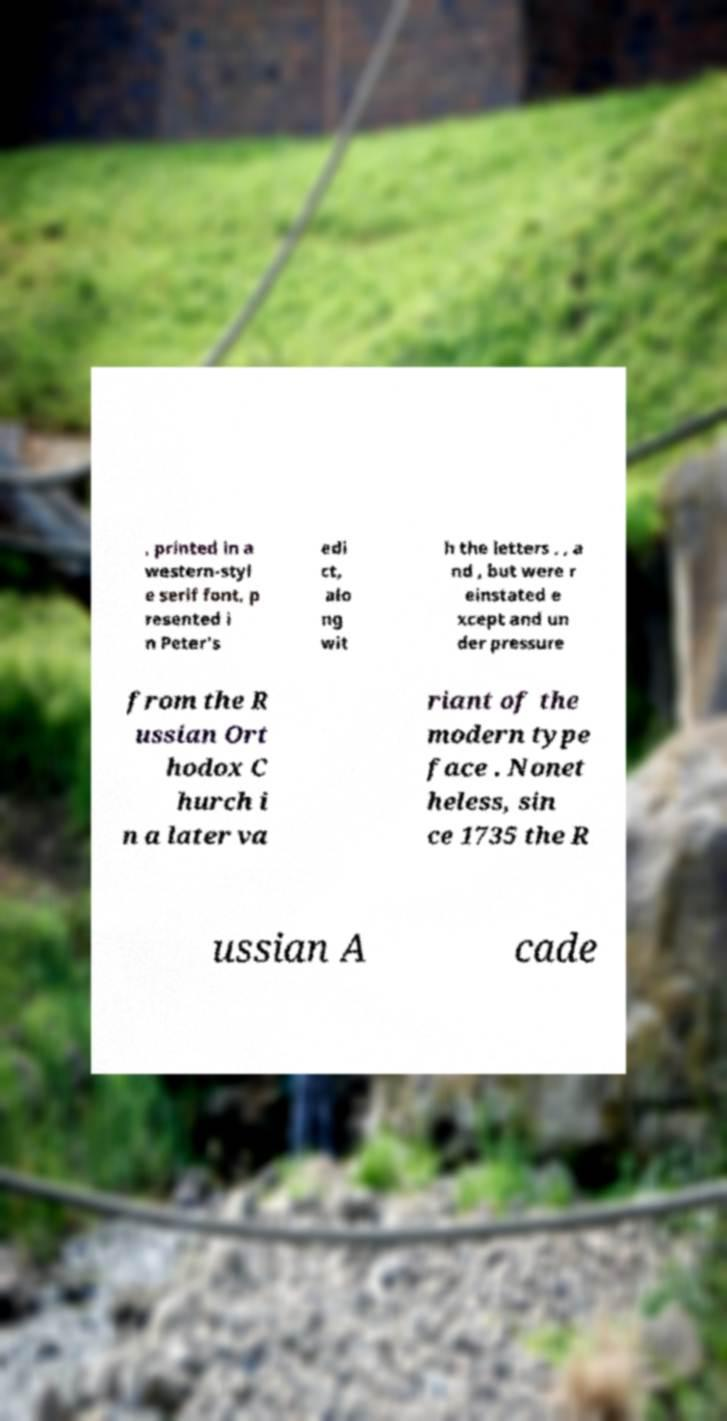I need the written content from this picture converted into text. Can you do that? , printed in a western-styl e serif font, p resented i n Peter's edi ct, alo ng wit h the letters , , a nd , but were r einstated e xcept and un der pressure from the R ussian Ort hodox C hurch i n a later va riant of the modern type face . Nonet heless, sin ce 1735 the R ussian A cade 